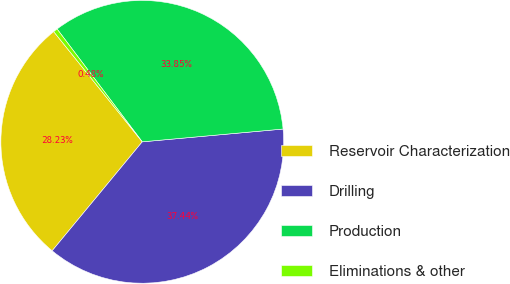<chart> <loc_0><loc_0><loc_500><loc_500><pie_chart><fcel>Reservoir Characterization<fcel>Drilling<fcel>Production<fcel>Eliminations & other<nl><fcel>28.23%<fcel>37.44%<fcel>33.85%<fcel>0.48%<nl></chart> 